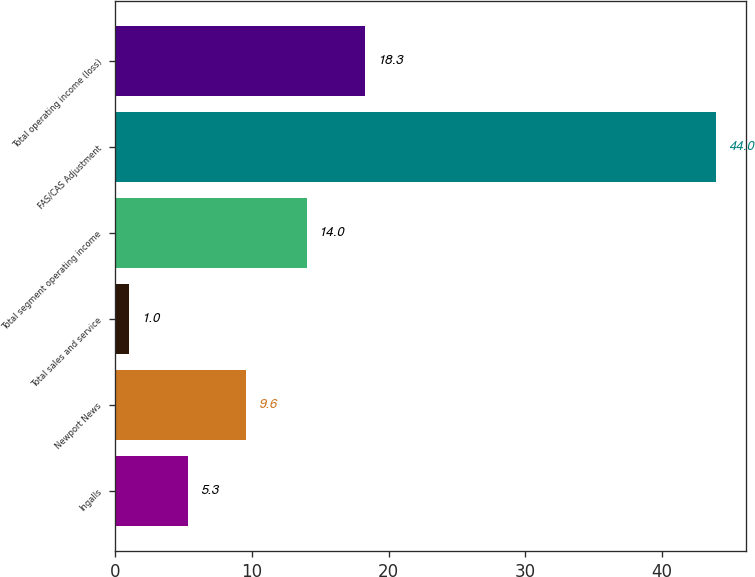Convert chart to OTSL. <chart><loc_0><loc_0><loc_500><loc_500><bar_chart><fcel>Ingalls<fcel>Newport News<fcel>Total sales and service<fcel>Total segment operating income<fcel>FAS/CAS Adjustment<fcel>Total operating income (loss)<nl><fcel>5.3<fcel>9.6<fcel>1<fcel>14<fcel>44<fcel>18.3<nl></chart> 